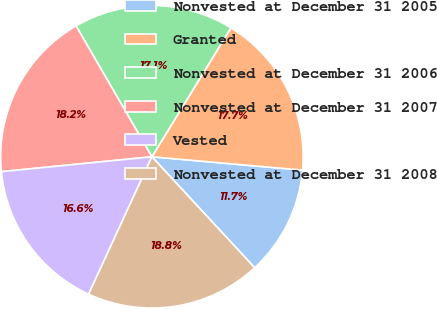Convert chart to OTSL. <chart><loc_0><loc_0><loc_500><loc_500><pie_chart><fcel>Nonvested at December 31 2005<fcel>Granted<fcel>Nonvested at December 31 2006<fcel>Nonvested at December 31 2007<fcel>Vested<fcel>Nonvested at December 31 2008<nl><fcel>11.7%<fcel>17.66%<fcel>17.11%<fcel>18.21%<fcel>16.56%<fcel>18.76%<nl></chart> 